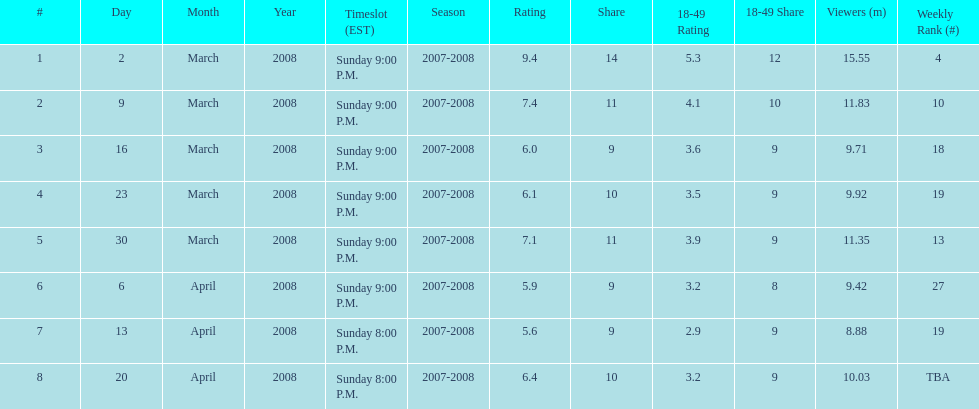Parse the table in full. {'header': ['#', 'Day', 'Month', 'Year', 'Timeslot (EST)', 'Season', 'Rating', 'Share', '18-49 Rating', '18-49 Share', 'Viewers (m)', 'Weekly Rank (#)'], 'rows': [['1', '2', 'March', '2008', 'Sunday 9:00 P.M.', '2007-2008', '9.4', '14', '5.3', '12', '15.55', '4'], ['2', '9', 'March', '2008', 'Sunday 9:00 P.M.', '2007-2008', '7.4', '11', '4.1', '10', '11.83', '10'], ['3', '16', 'March', '2008', 'Sunday 9:00 P.M.', '2007-2008', '6.0', '9', '3.6', '9', '9.71', '18'], ['4', '23', 'March', '2008', 'Sunday 9:00 P.M.', '2007-2008', '6.1', '10', '3.5', '9', '9.92', '19'], ['5', '30', 'March', '2008', 'Sunday 9:00 P.M.', '2007-2008', '7.1', '11', '3.9', '9', '11.35', '13'], ['6', '6', 'April', '2008', 'Sunday 9:00 P.M.', '2007-2008', '5.9', '9', '3.2', '8', '9.42', '27'], ['7', '13', 'April', '2008', 'Sunday 8:00 P.M.', '2007-2008', '5.6', '9', '2.9', '9', '8.88', '19'], ['8', '20', 'April', '2008', 'Sunday 8:00 P.M.', '2007-2008', '6.4', '10', '3.2', '9', '10.03', 'TBA']]} Which show had the highest rating? 1. 